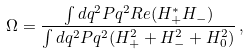Convert formula to latex. <formula><loc_0><loc_0><loc_500><loc_500>\Omega = { \frac { \int d q ^ { 2 } P q ^ { 2 } R e ( H _ { + } ^ { * } H _ { - } ) } { \int d q ^ { 2 } P q ^ { 2 } ( H _ { + } ^ { 2 } + H _ { - } ^ { 2 } + H _ { 0 } ^ { 2 } ) } } \, ,</formula> 